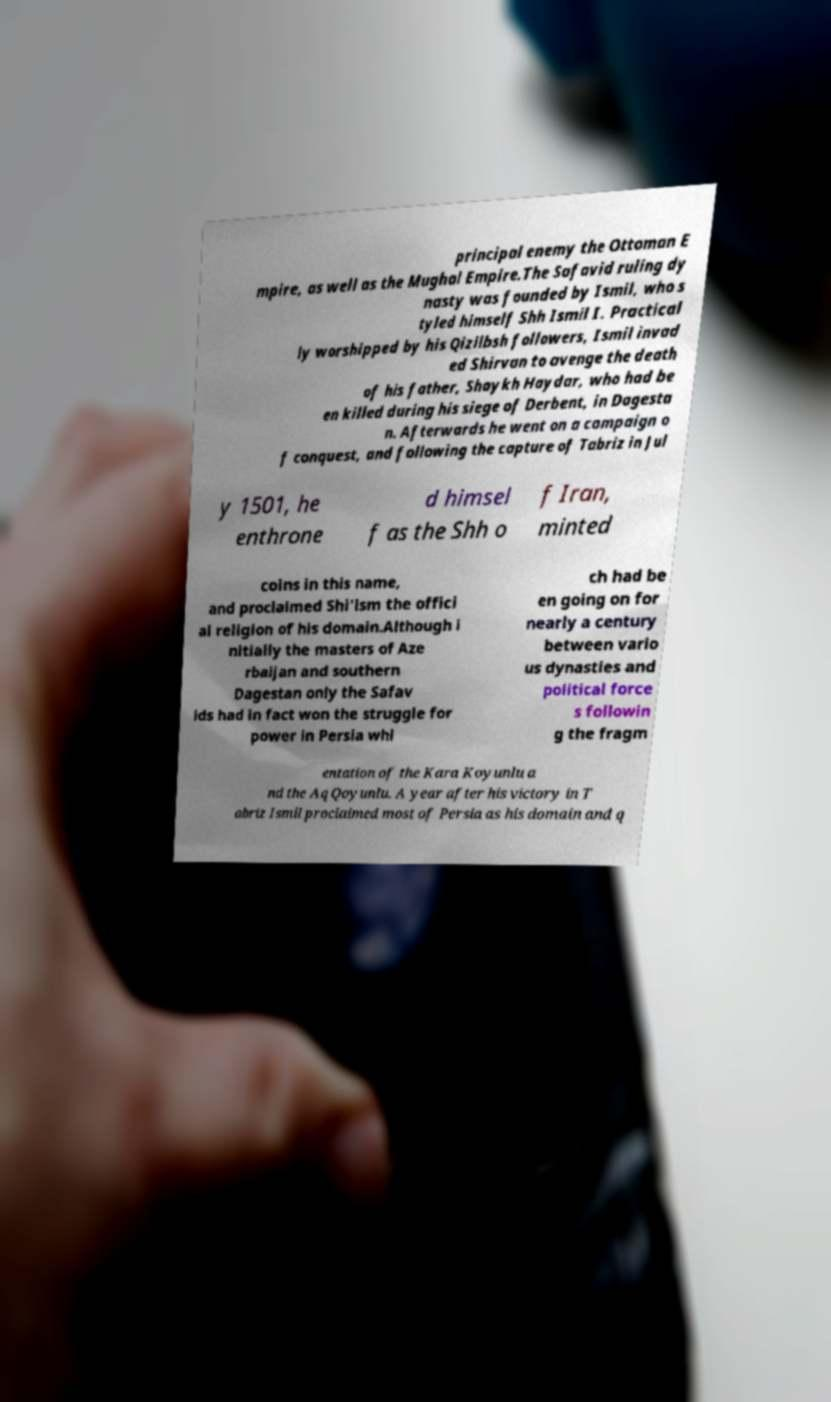What messages or text are displayed in this image? I need them in a readable, typed format. principal enemy the Ottoman E mpire, as well as the Mughal Empire.The Safavid ruling dy nasty was founded by Ismil, who s tyled himself Shh Ismil I. Practical ly worshipped by his Qizilbsh followers, Ismil invad ed Shirvan to avenge the death of his father, Shaykh Haydar, who had be en killed during his siege of Derbent, in Dagesta n. Afterwards he went on a campaign o f conquest, and following the capture of Tabriz in Jul y 1501, he enthrone d himsel f as the Shh o f Iran, minted coins in this name, and proclaimed Shi'ism the offici al religion of his domain.Although i nitially the masters of Aze rbaijan and southern Dagestan only the Safav ids had in fact won the struggle for power in Persia whi ch had be en going on for nearly a century between vario us dynasties and political force s followin g the fragm entation of the Kara Koyunlu a nd the Aq Qoyunlu. A year after his victory in T abriz Ismil proclaimed most of Persia as his domain and q 